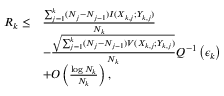<formula> <loc_0><loc_0><loc_500><loc_500>\begin{array} { r l } { R _ { k } \leq } & { \frac { \sum _ { j = 1 } ^ { k } ( N _ { j } - N _ { j - 1 } ) I ( X _ { k , j } ; Y _ { k , j } ) } { N _ { k } } } \\ & { - \frac { \sqrt { \sum _ { j = 1 } ^ { k } ( N _ { j } - N _ { j - 1 } ) V ( X _ { k , j } ; Y _ { k , j } ) } } { N _ { k } } Q ^ { - 1 } \left ( \epsilon _ { k } \right ) } \\ & { + O \left ( \frac { \log N _ { k } } { N _ { k } } \right ) , } \end{array}</formula> 